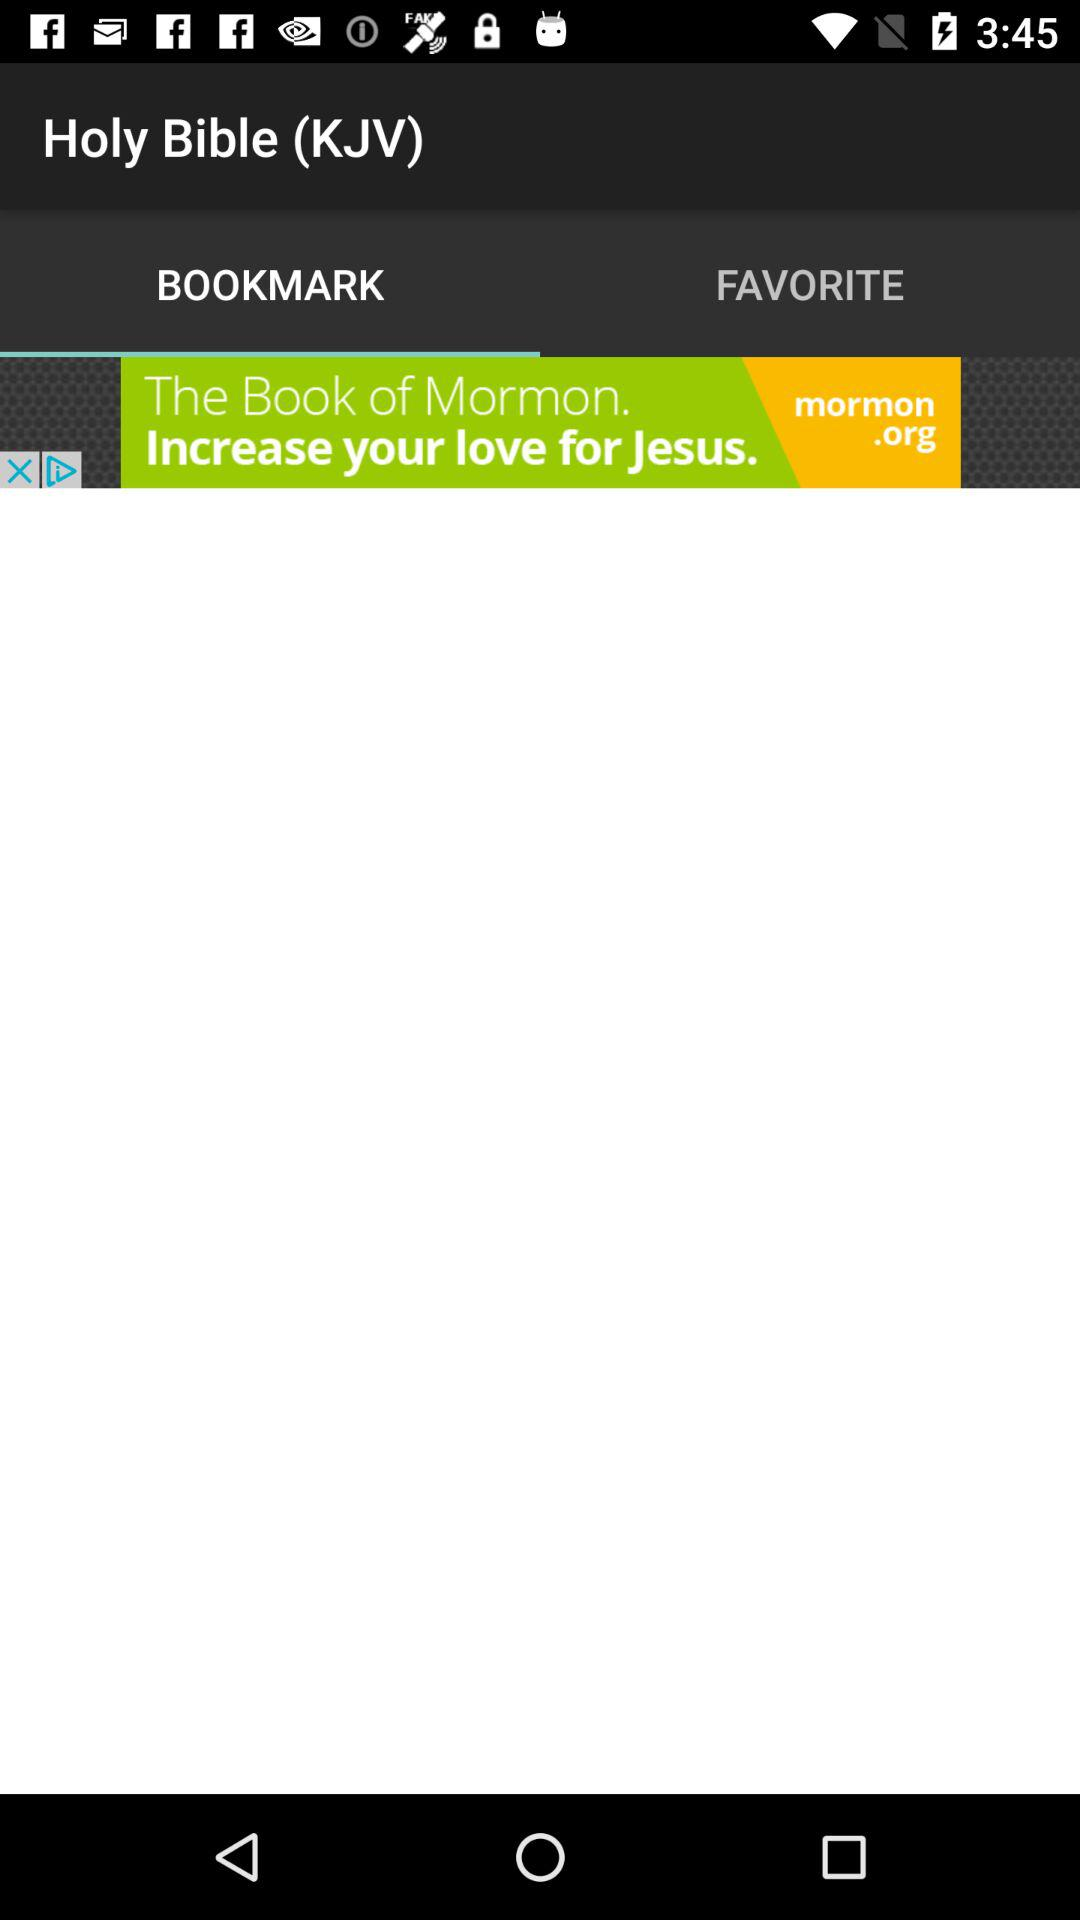Which is the selected tab? The selected tab is "BOOKMARK". 